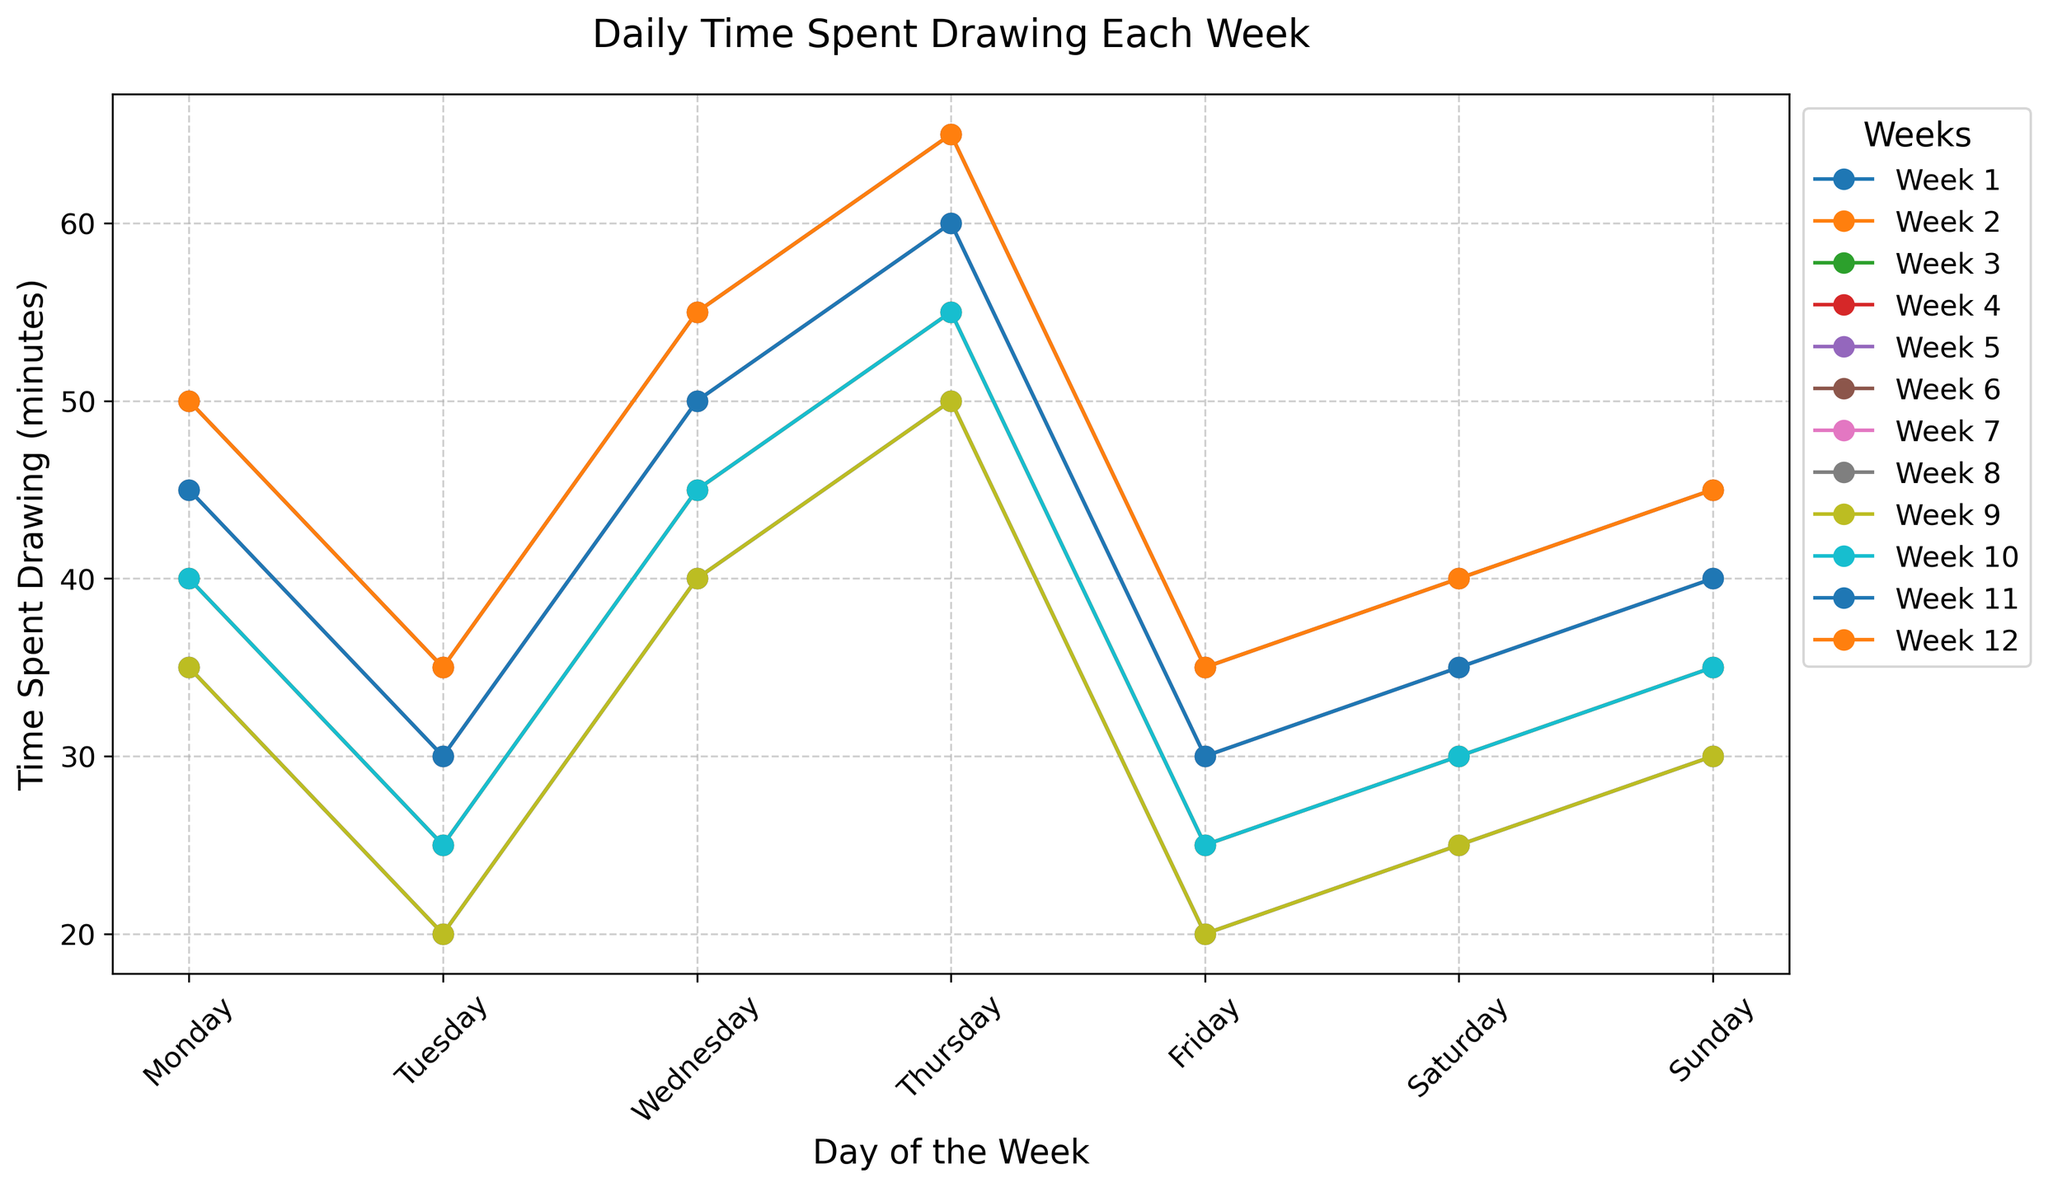Which day of the week did you spend the most time drawing in Week 1? To find the day with the most time spent drawing, look for the highest point in Week 1's line on the graph. This peak corresponds to Sunday, where the time spent drawing is highest.
Answer: Sunday How many more minutes did you spend drawing on Saturdays compared to Thursdays in Week 3? Identify the points for Saturday and Thursday in Week 3. Saturday has 50 minutes, and Thursday has 30 minutes. Subtract Thursday's time from Saturday's: 50 - 30 = 20.
Answer: 20 minutes On which day did you spend the least amount of time drawing in Week 12? To find the day with the least time spent drawing, look for the lowest point in Week 12's line on the graph. This is Monday, where the time spent drawing is 35 minutes.
Answer: Monday What is the average time spent drawing on Wednesdays across all the weeks? First, find the time spent drawing each Wednesday: 30, 35, 40, 45, 30, 35, 40, 45, 30, 35, 40, 45. Then, sum these values: 30 + 35 + 40 + 45 + 30 + 35 + 40 + 45 + 30 + 35 + 40 + 45 = 450. Finally, divide by the number of weeks (12): 450 / 12 = 37.5.
Answer: 37.5 minutes Which week had the highest overall time spent drawing on Sundays? Compare the points for all Sundays across the weeks. The highest point is in Week 4, Week 8, and Week 12, where the time spent is 65 minutes.
Answer: Week 4, Week 8, Week 12 Did you spend more time drawing on Fridays or Saturdays in Week 5? Compare the points for Friday and Saturday in Week 5. Friday has 35 minutes and Saturday has 40 minutes. Saturday has more time spent drawing.
Answer: Saturday How does the time spent drawing on Mondays compare between Week 1 and Week 10? Check the points for Monday in Week 1 and Week 10. Week 1 has 20 minutes, and Week 10 has 25 minutes. Week 10 has 5 more minutes than Week 1.
Answer: Week 10, 5 more minutes What is the trend in time spent drawing on Sundays from Week 1 to Week 12? Observe the points for Sundays across all weeks. The trend shows a consistent increase, with times going from 50 minutes in Week 1 to 65 minutes in Week 12.
Answer: Increasing How many weeks show an increase in time spent drawing from Monday to Sunday? Identify weeks where the points on Sunday are higher than Monday. These weeks are: Week 1, Week 2, Week 3, Week 4, Week 6, Week 7, Week 8, Week 10, Week 11, Week 12. Count these weeks: 10 weeks.
Answer: 10 weeks 